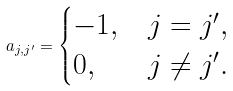<formula> <loc_0><loc_0><loc_500><loc_500>a _ { j , j ^ { \prime } } = \begin{cases} - 1 , & j = j ^ { \prime } , \\ 0 , & j \neq j ^ { \prime } . \end{cases}</formula> 